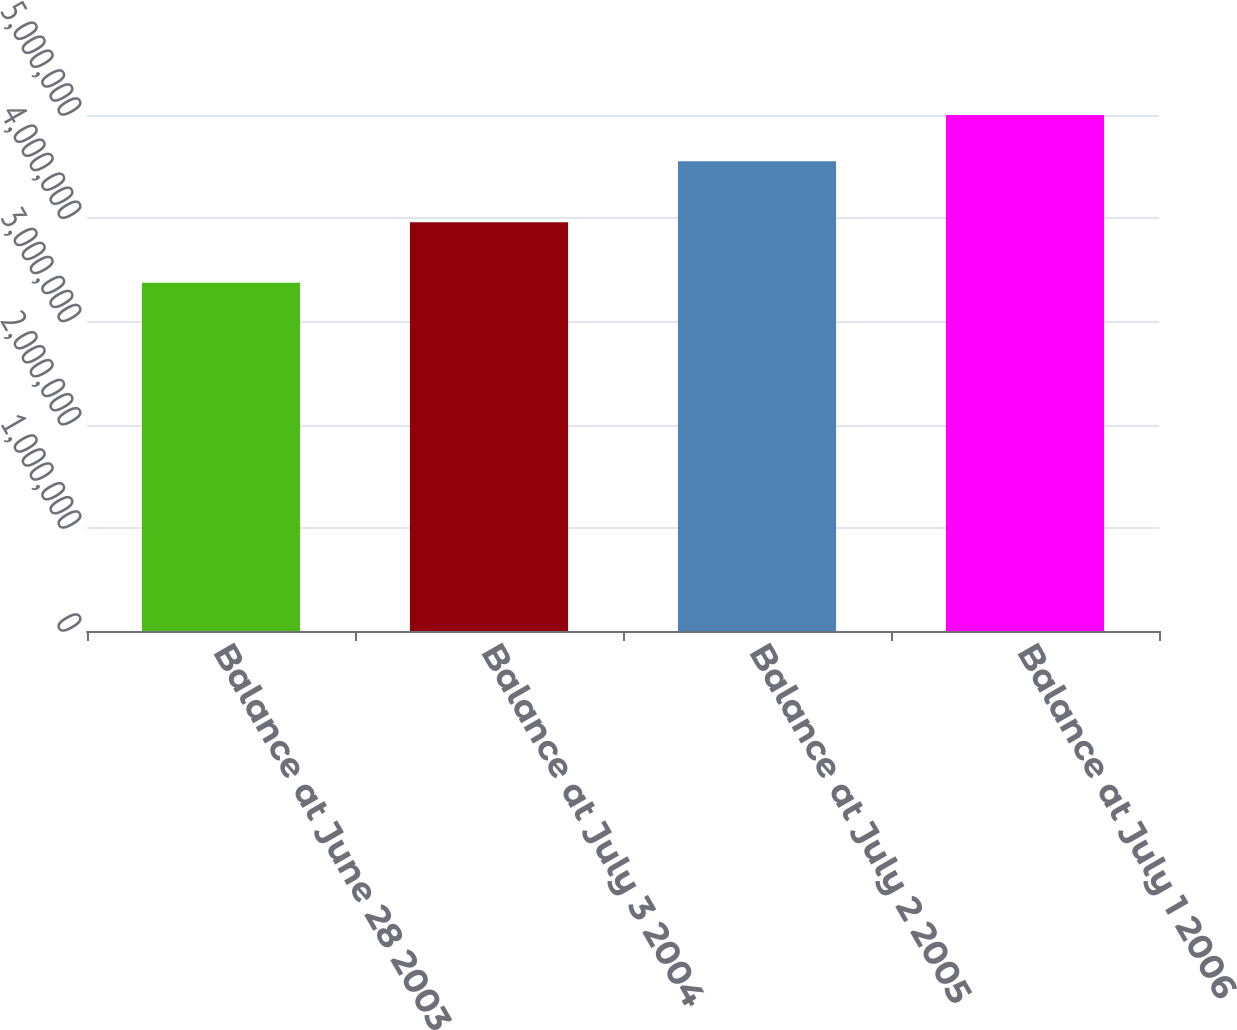Convert chart. <chart><loc_0><loc_0><loc_500><loc_500><bar_chart><fcel>Balance at June 28 2003<fcel>Balance at July 3 2004<fcel>Balance at July 2 2005<fcel>Balance at July 1 2006<nl><fcel>3.37385e+06<fcel>3.95971e+06<fcel>4.55238e+06<fcel>4.99944e+06<nl></chart> 